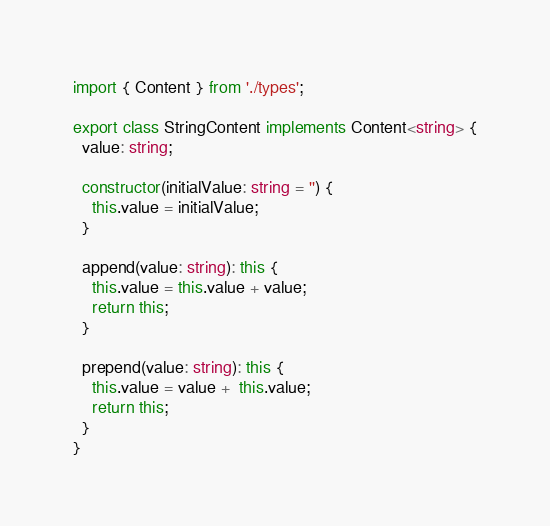<code> <loc_0><loc_0><loc_500><loc_500><_TypeScript_>import { Content } from './types';

export class StringContent implements Content<string> {
  value: string;

  constructor(initialValue: string = '') {
    this.value = initialValue;
  }

  append(value: string): this {
    this.value = this.value + value;
    return this;
  }

  prepend(value: string): this {
    this.value = value +  this.value;
    return this;
  }
}
</code> 